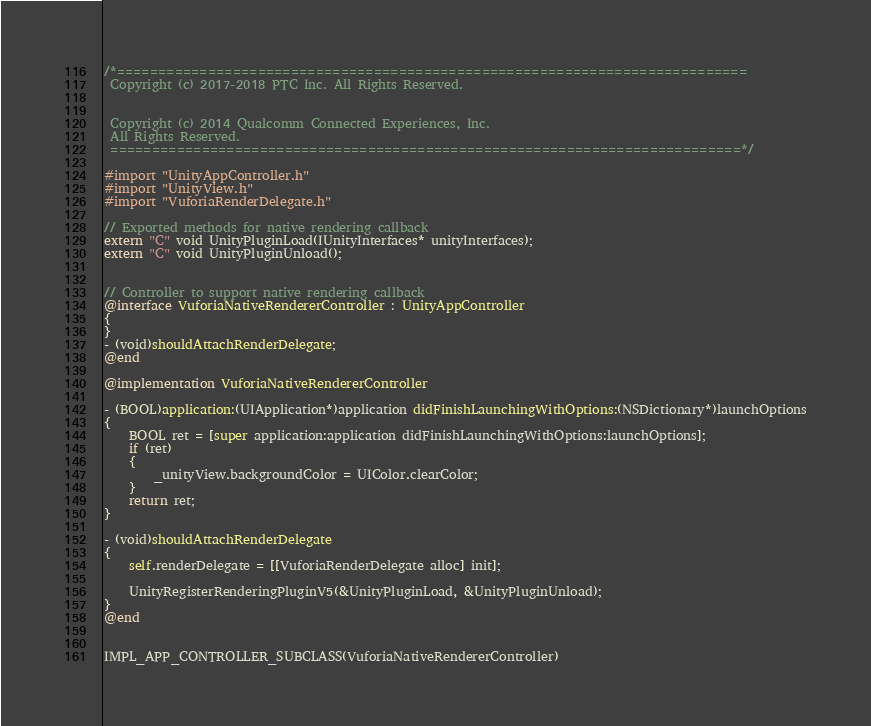<code> <loc_0><loc_0><loc_500><loc_500><_ObjectiveC_>/*============================================================================
 Copyright (c) 2017-2018 PTC Inc. All Rights Reserved.
 
 
 Copyright (c) 2014 Qualcomm Connected Experiences, Inc.
 All Rights Reserved.
 ============================================================================*/

#import "UnityAppController.h"
#import "UnityView.h"
#import "VuforiaRenderDelegate.h"

// Exported methods for native rendering callback
extern "C" void UnityPluginLoad(IUnityInterfaces* unityInterfaces);
extern "C" void UnityPluginUnload();


// Controller to support native rendering callback
@interface VuforiaNativeRendererController : UnityAppController
{
}
- (void)shouldAttachRenderDelegate;
@end

@implementation VuforiaNativeRendererController

- (BOOL)application:(UIApplication*)application didFinishLaunchingWithOptions:(NSDictionary*)launchOptions
{
    BOOL ret = [super application:application didFinishLaunchingWithOptions:launchOptions];
    if (ret)
    {
        _unityView.backgroundColor = UIColor.clearColor;
    }
    return ret;
}

- (void)shouldAttachRenderDelegate
{
    self.renderDelegate = [[VuforiaRenderDelegate alloc] init];

    UnityRegisterRenderingPluginV5(&UnityPluginLoad, &UnityPluginUnload);
}
@end


IMPL_APP_CONTROLLER_SUBCLASS(VuforiaNativeRendererController)
</code> 